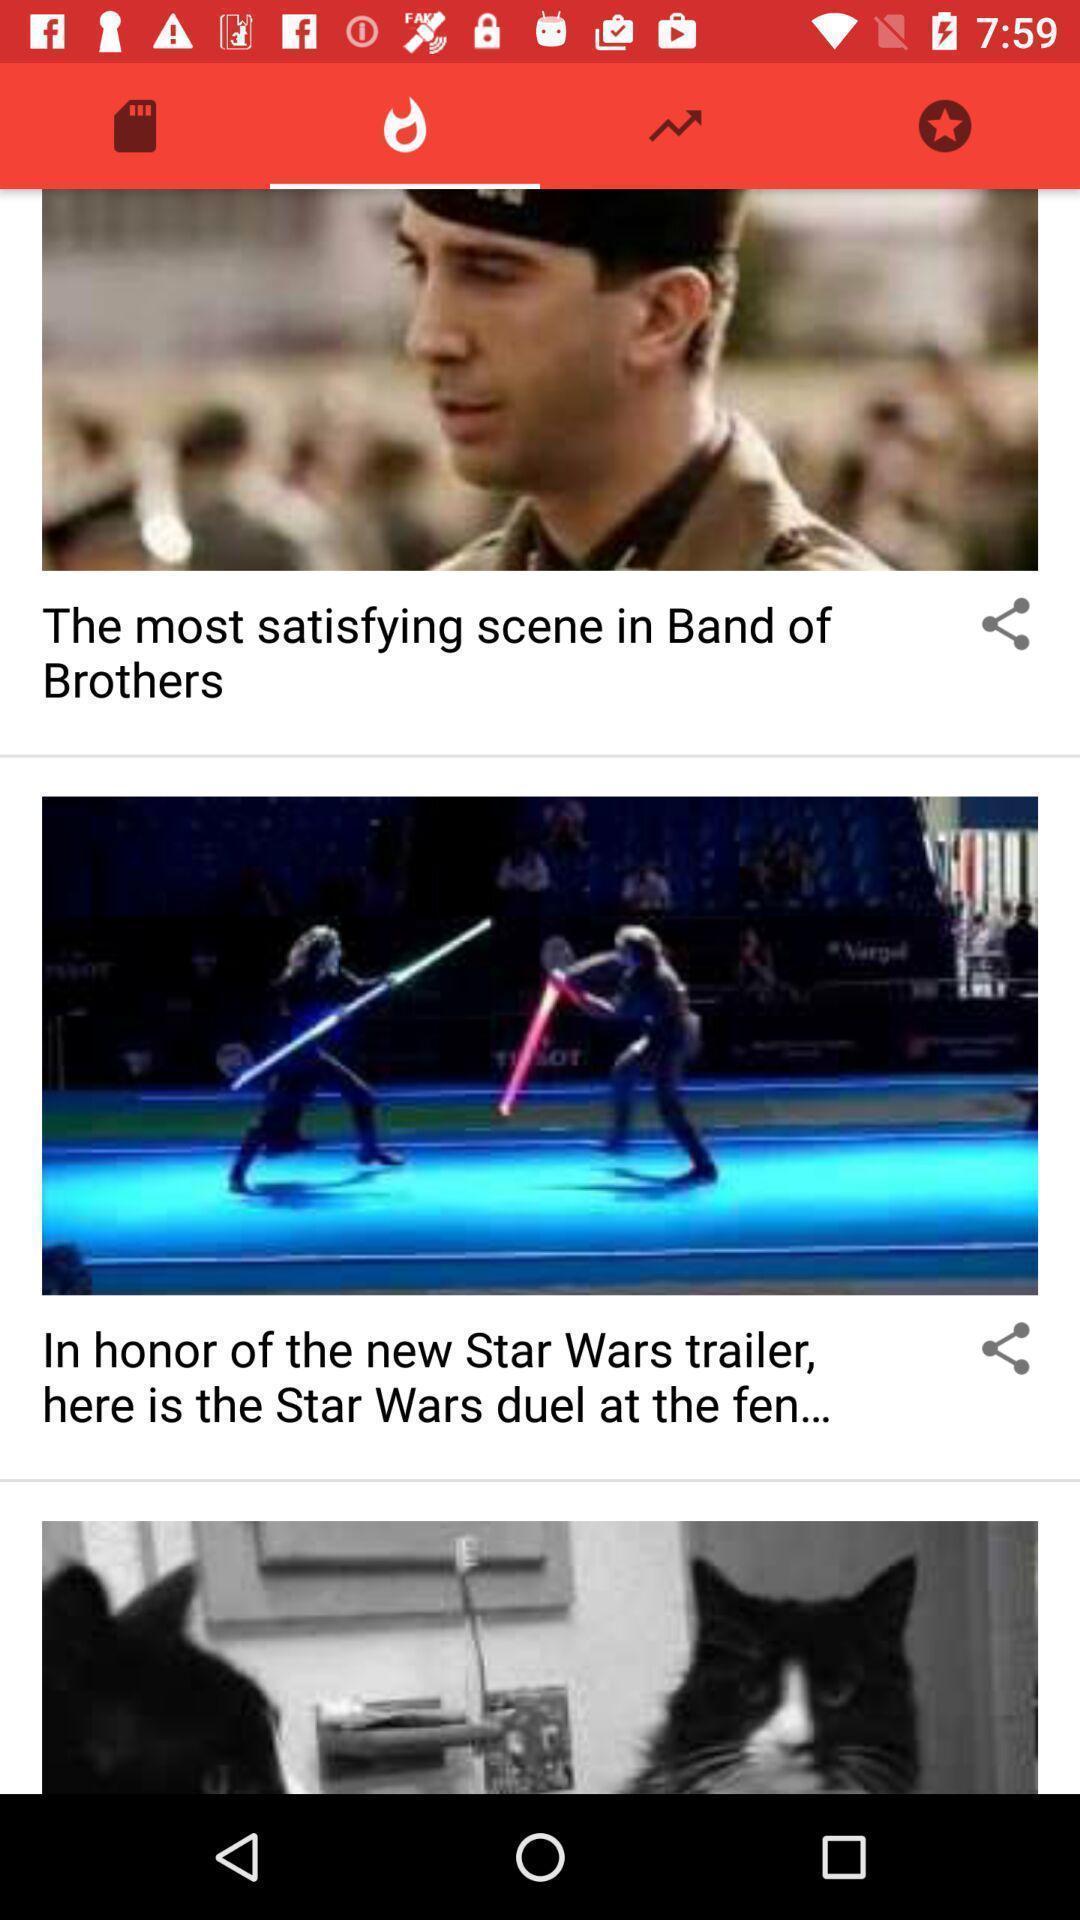Explain what's happening in this screen capture. Window displaying different trending news. 